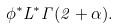Convert formula to latex. <formula><loc_0><loc_0><loc_500><loc_500>\phi ^ { * } L ^ { * } \Gamma ( 2 + \alpha ) .</formula> 